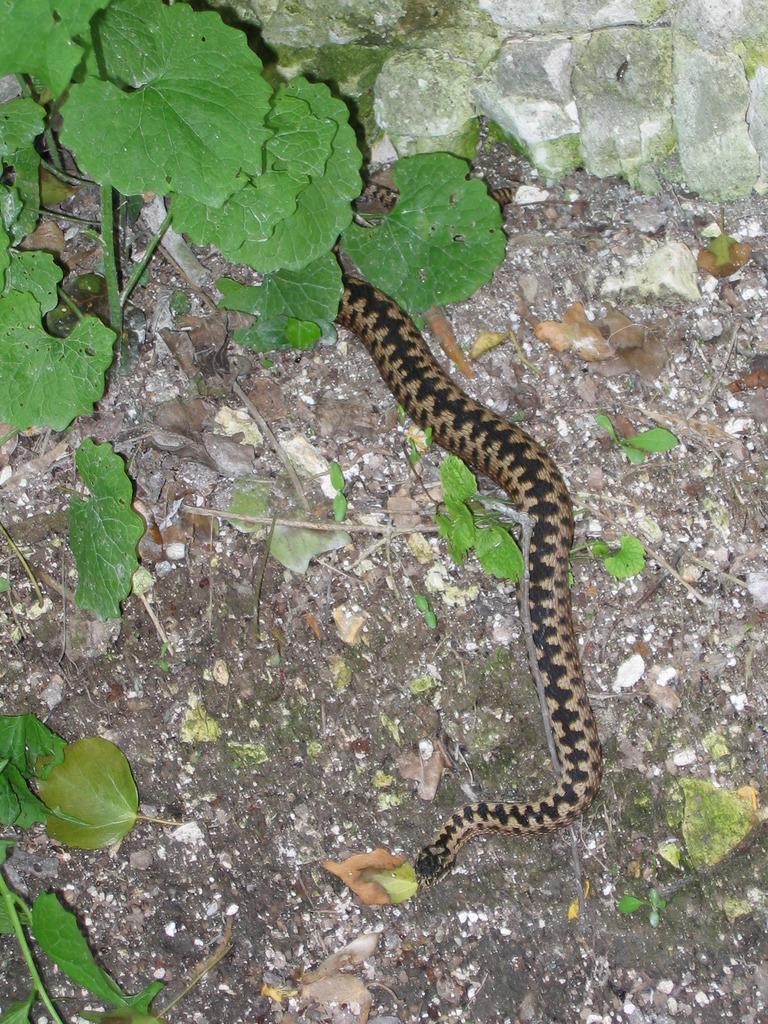Describe this image in one or two sentences. There is a snake on the ground. On the ground there are leaves and a plant. 